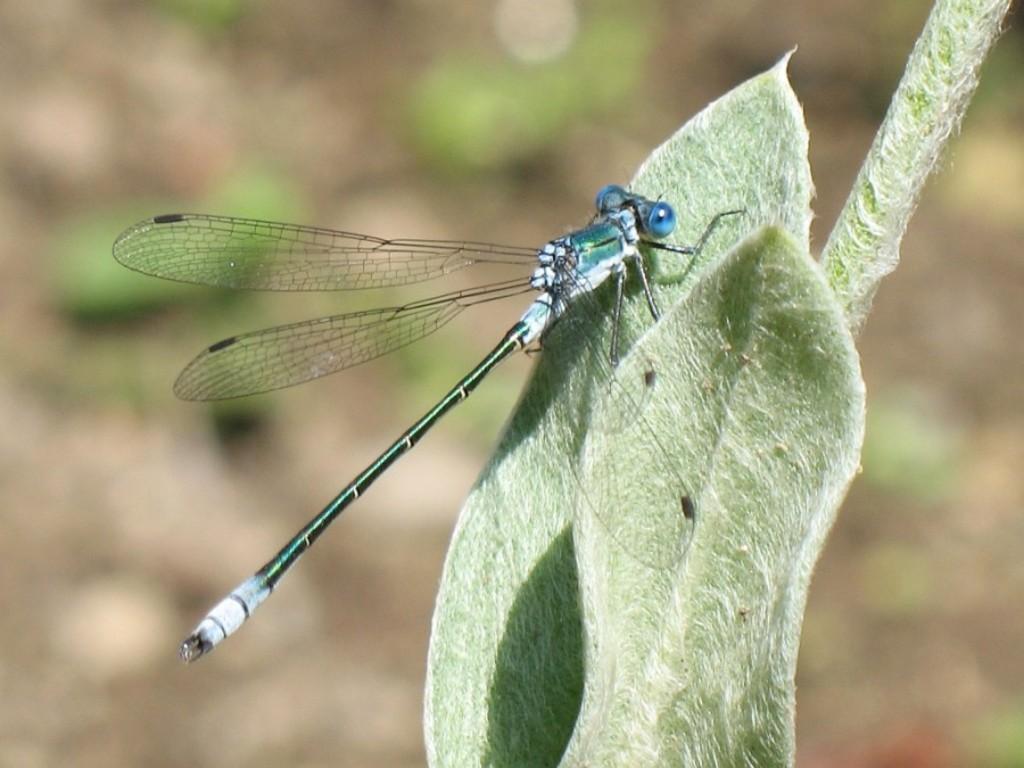Describe this image in one or two sentences. This image is taken outdoors. In this image the background is blurred. On the right side of the image there is a plant. In the middle of the image there is a plant. In the middle of the image there is a dragonfly on the leaf. 